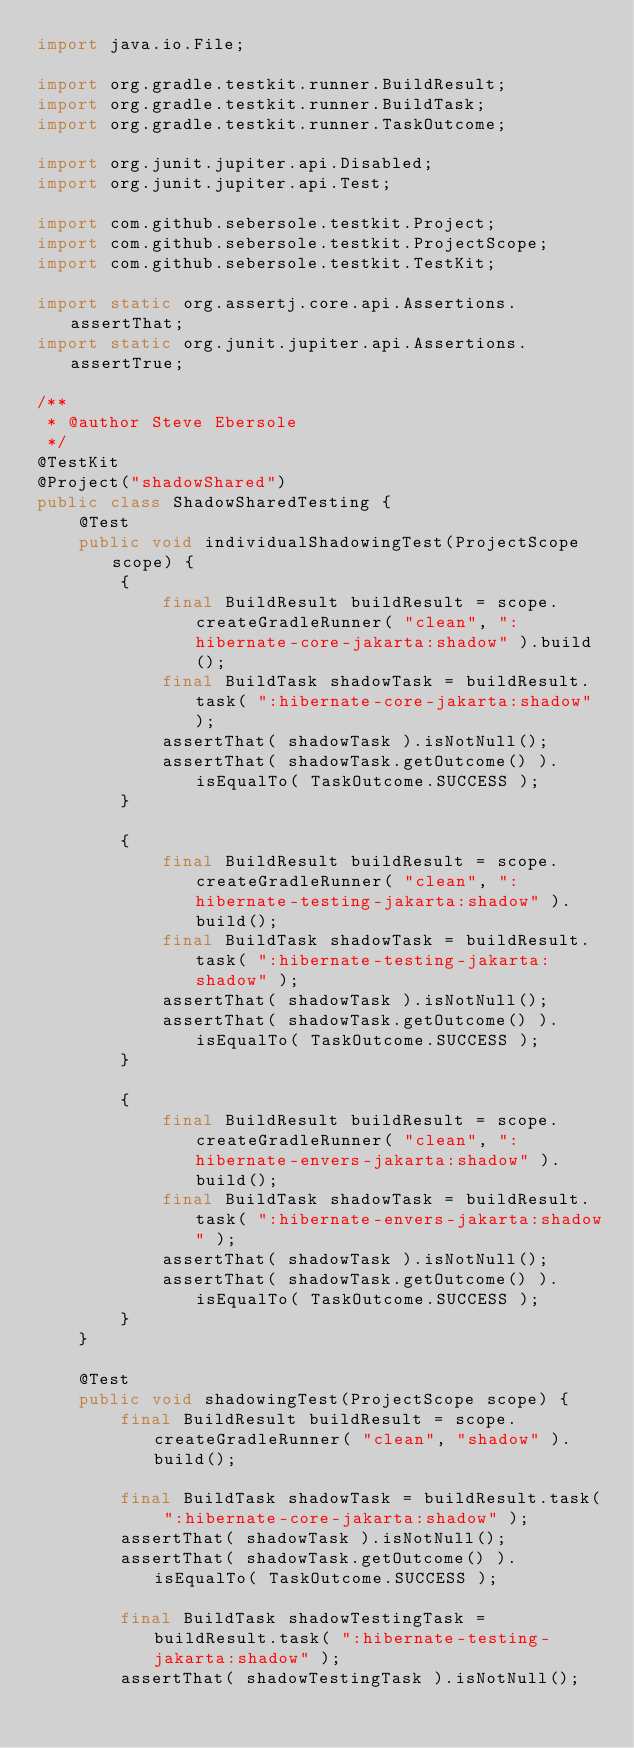Convert code to text. <code><loc_0><loc_0><loc_500><loc_500><_Java_>import java.io.File;

import org.gradle.testkit.runner.BuildResult;
import org.gradle.testkit.runner.BuildTask;
import org.gradle.testkit.runner.TaskOutcome;

import org.junit.jupiter.api.Disabled;
import org.junit.jupiter.api.Test;

import com.github.sebersole.testkit.Project;
import com.github.sebersole.testkit.ProjectScope;
import com.github.sebersole.testkit.TestKit;

import static org.assertj.core.api.Assertions.assertThat;
import static org.junit.jupiter.api.Assertions.assertTrue;

/**
 * @author Steve Ebersole
 */
@TestKit
@Project("shadowShared")
public class ShadowSharedTesting {
	@Test
	public void individualShadowingTest(ProjectScope scope) {
		{
			final BuildResult buildResult = scope.createGradleRunner( "clean", ":hibernate-core-jakarta:shadow" ).build();
			final BuildTask shadowTask = buildResult.task( ":hibernate-core-jakarta:shadow" );
			assertThat( shadowTask ).isNotNull();
			assertThat( shadowTask.getOutcome() ).isEqualTo( TaskOutcome.SUCCESS );
		}

		{
			final BuildResult buildResult = scope.createGradleRunner( "clean", ":hibernate-testing-jakarta:shadow" ).build();
			final BuildTask shadowTask = buildResult.task( ":hibernate-testing-jakarta:shadow" );
			assertThat( shadowTask ).isNotNull();
			assertThat( shadowTask.getOutcome() ).isEqualTo( TaskOutcome.SUCCESS );
		}

		{
			final BuildResult buildResult = scope.createGradleRunner( "clean", ":hibernate-envers-jakarta:shadow" ).build();
			final BuildTask shadowTask = buildResult.task( ":hibernate-envers-jakarta:shadow" );
			assertThat( shadowTask ).isNotNull();
			assertThat( shadowTask.getOutcome() ).isEqualTo( TaskOutcome.SUCCESS );
		}
	}

	@Test
	public void shadowingTest(ProjectScope scope) {
		final BuildResult buildResult = scope.createGradleRunner( "clean", "shadow" ).build();

		final BuildTask shadowTask = buildResult.task( ":hibernate-core-jakarta:shadow" );
		assertThat( shadowTask ).isNotNull();
		assertThat( shadowTask.getOutcome() ).isEqualTo( TaskOutcome.SUCCESS );

		final BuildTask shadowTestingTask = buildResult.task( ":hibernate-testing-jakarta:shadow" );
		assertThat( shadowTestingTask ).isNotNull();</code> 